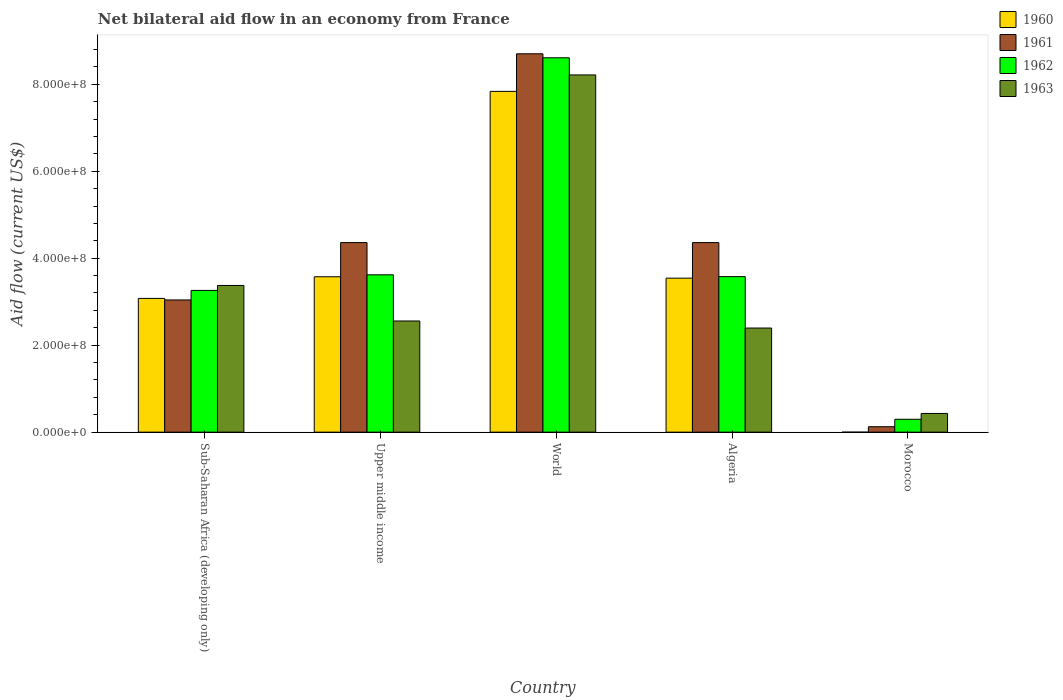How many different coloured bars are there?
Keep it short and to the point. 4. Are the number of bars on each tick of the X-axis equal?
Give a very brief answer. No. How many bars are there on the 4th tick from the left?
Your response must be concise. 4. What is the label of the 2nd group of bars from the left?
Ensure brevity in your answer.  Upper middle income. What is the net bilateral aid flow in 1963 in World?
Give a very brief answer. 8.21e+08. Across all countries, what is the maximum net bilateral aid flow in 1960?
Provide a short and direct response. 7.84e+08. Across all countries, what is the minimum net bilateral aid flow in 1962?
Make the answer very short. 2.96e+07. In which country was the net bilateral aid flow in 1960 maximum?
Give a very brief answer. World. What is the total net bilateral aid flow in 1960 in the graph?
Give a very brief answer. 1.80e+09. What is the difference between the net bilateral aid flow in 1962 in Algeria and that in Morocco?
Provide a succinct answer. 3.28e+08. What is the difference between the net bilateral aid flow in 1961 in Sub-Saharan Africa (developing only) and the net bilateral aid flow in 1962 in Algeria?
Make the answer very short. -5.36e+07. What is the average net bilateral aid flow in 1960 per country?
Offer a terse response. 3.60e+08. What is the difference between the net bilateral aid flow of/in 1961 and net bilateral aid flow of/in 1962 in Sub-Saharan Africa (developing only)?
Provide a succinct answer. -2.19e+07. In how many countries, is the net bilateral aid flow in 1962 greater than 80000000 US$?
Offer a very short reply. 4. What is the ratio of the net bilateral aid flow in 1963 in Morocco to that in Sub-Saharan Africa (developing only)?
Make the answer very short. 0.13. Is the net bilateral aid flow in 1963 in Morocco less than that in Sub-Saharan Africa (developing only)?
Your response must be concise. Yes. Is the difference between the net bilateral aid flow in 1961 in Morocco and World greater than the difference between the net bilateral aid flow in 1962 in Morocco and World?
Your answer should be compact. No. What is the difference between the highest and the second highest net bilateral aid flow in 1961?
Offer a terse response. 4.34e+08. What is the difference between the highest and the lowest net bilateral aid flow in 1961?
Provide a succinct answer. 8.58e+08. Is the sum of the net bilateral aid flow in 1960 in Algeria and World greater than the maximum net bilateral aid flow in 1961 across all countries?
Keep it short and to the point. Yes. Is it the case that in every country, the sum of the net bilateral aid flow in 1962 and net bilateral aid flow in 1961 is greater than the net bilateral aid flow in 1963?
Your response must be concise. No. What is the difference between two consecutive major ticks on the Y-axis?
Your response must be concise. 2.00e+08. Are the values on the major ticks of Y-axis written in scientific E-notation?
Keep it short and to the point. Yes. Does the graph contain any zero values?
Provide a succinct answer. Yes. Where does the legend appear in the graph?
Your answer should be compact. Top right. How many legend labels are there?
Give a very brief answer. 4. What is the title of the graph?
Make the answer very short. Net bilateral aid flow in an economy from France. What is the label or title of the Y-axis?
Keep it short and to the point. Aid flow (current US$). What is the Aid flow (current US$) in 1960 in Sub-Saharan Africa (developing only)?
Ensure brevity in your answer.  3.08e+08. What is the Aid flow (current US$) of 1961 in Sub-Saharan Africa (developing only)?
Give a very brief answer. 3.04e+08. What is the Aid flow (current US$) in 1962 in Sub-Saharan Africa (developing only)?
Offer a terse response. 3.26e+08. What is the Aid flow (current US$) in 1963 in Sub-Saharan Africa (developing only)?
Offer a terse response. 3.37e+08. What is the Aid flow (current US$) of 1960 in Upper middle income?
Your response must be concise. 3.57e+08. What is the Aid flow (current US$) of 1961 in Upper middle income?
Offer a very short reply. 4.36e+08. What is the Aid flow (current US$) in 1962 in Upper middle income?
Ensure brevity in your answer.  3.62e+08. What is the Aid flow (current US$) in 1963 in Upper middle income?
Your answer should be very brief. 2.56e+08. What is the Aid flow (current US$) in 1960 in World?
Ensure brevity in your answer.  7.84e+08. What is the Aid flow (current US$) of 1961 in World?
Keep it short and to the point. 8.70e+08. What is the Aid flow (current US$) in 1962 in World?
Provide a succinct answer. 8.61e+08. What is the Aid flow (current US$) in 1963 in World?
Keep it short and to the point. 8.21e+08. What is the Aid flow (current US$) of 1960 in Algeria?
Your response must be concise. 3.54e+08. What is the Aid flow (current US$) in 1961 in Algeria?
Make the answer very short. 4.36e+08. What is the Aid flow (current US$) in 1962 in Algeria?
Give a very brief answer. 3.58e+08. What is the Aid flow (current US$) of 1963 in Algeria?
Offer a very short reply. 2.39e+08. What is the Aid flow (current US$) in 1961 in Morocco?
Give a very brief answer. 1.25e+07. What is the Aid flow (current US$) of 1962 in Morocco?
Make the answer very short. 2.96e+07. What is the Aid flow (current US$) of 1963 in Morocco?
Provide a succinct answer. 4.30e+07. Across all countries, what is the maximum Aid flow (current US$) in 1960?
Your answer should be compact. 7.84e+08. Across all countries, what is the maximum Aid flow (current US$) in 1961?
Ensure brevity in your answer.  8.70e+08. Across all countries, what is the maximum Aid flow (current US$) of 1962?
Give a very brief answer. 8.61e+08. Across all countries, what is the maximum Aid flow (current US$) of 1963?
Your response must be concise. 8.21e+08. Across all countries, what is the minimum Aid flow (current US$) in 1961?
Your answer should be very brief. 1.25e+07. Across all countries, what is the minimum Aid flow (current US$) in 1962?
Offer a terse response. 2.96e+07. Across all countries, what is the minimum Aid flow (current US$) of 1963?
Give a very brief answer. 4.30e+07. What is the total Aid flow (current US$) of 1960 in the graph?
Offer a very short reply. 1.80e+09. What is the total Aid flow (current US$) of 1961 in the graph?
Give a very brief answer. 2.06e+09. What is the total Aid flow (current US$) in 1962 in the graph?
Ensure brevity in your answer.  1.94e+09. What is the total Aid flow (current US$) of 1963 in the graph?
Offer a very short reply. 1.70e+09. What is the difference between the Aid flow (current US$) in 1960 in Sub-Saharan Africa (developing only) and that in Upper middle income?
Offer a terse response. -4.98e+07. What is the difference between the Aid flow (current US$) in 1961 in Sub-Saharan Africa (developing only) and that in Upper middle income?
Keep it short and to the point. -1.32e+08. What is the difference between the Aid flow (current US$) in 1962 in Sub-Saharan Africa (developing only) and that in Upper middle income?
Your answer should be compact. -3.59e+07. What is the difference between the Aid flow (current US$) in 1963 in Sub-Saharan Africa (developing only) and that in Upper middle income?
Keep it short and to the point. 8.17e+07. What is the difference between the Aid flow (current US$) of 1960 in Sub-Saharan Africa (developing only) and that in World?
Keep it short and to the point. -4.76e+08. What is the difference between the Aid flow (current US$) of 1961 in Sub-Saharan Africa (developing only) and that in World?
Provide a short and direct response. -5.66e+08. What is the difference between the Aid flow (current US$) of 1962 in Sub-Saharan Africa (developing only) and that in World?
Your response must be concise. -5.35e+08. What is the difference between the Aid flow (current US$) of 1963 in Sub-Saharan Africa (developing only) and that in World?
Your response must be concise. -4.84e+08. What is the difference between the Aid flow (current US$) of 1960 in Sub-Saharan Africa (developing only) and that in Algeria?
Your answer should be compact. -4.66e+07. What is the difference between the Aid flow (current US$) in 1961 in Sub-Saharan Africa (developing only) and that in Algeria?
Your response must be concise. -1.32e+08. What is the difference between the Aid flow (current US$) in 1962 in Sub-Saharan Africa (developing only) and that in Algeria?
Offer a very short reply. -3.17e+07. What is the difference between the Aid flow (current US$) of 1963 in Sub-Saharan Africa (developing only) and that in Algeria?
Ensure brevity in your answer.  9.79e+07. What is the difference between the Aid flow (current US$) of 1961 in Sub-Saharan Africa (developing only) and that in Morocco?
Offer a terse response. 2.92e+08. What is the difference between the Aid flow (current US$) in 1962 in Sub-Saharan Africa (developing only) and that in Morocco?
Offer a very short reply. 2.96e+08. What is the difference between the Aid flow (current US$) in 1963 in Sub-Saharan Africa (developing only) and that in Morocco?
Ensure brevity in your answer.  2.94e+08. What is the difference between the Aid flow (current US$) in 1960 in Upper middle income and that in World?
Your response must be concise. -4.26e+08. What is the difference between the Aid flow (current US$) of 1961 in Upper middle income and that in World?
Offer a very short reply. -4.34e+08. What is the difference between the Aid flow (current US$) in 1962 in Upper middle income and that in World?
Give a very brief answer. -4.99e+08. What is the difference between the Aid flow (current US$) in 1963 in Upper middle income and that in World?
Offer a terse response. -5.66e+08. What is the difference between the Aid flow (current US$) in 1960 in Upper middle income and that in Algeria?
Your answer should be compact. 3.20e+06. What is the difference between the Aid flow (current US$) in 1962 in Upper middle income and that in Algeria?
Offer a terse response. 4.20e+06. What is the difference between the Aid flow (current US$) of 1963 in Upper middle income and that in Algeria?
Ensure brevity in your answer.  1.62e+07. What is the difference between the Aid flow (current US$) of 1961 in Upper middle income and that in Morocco?
Your answer should be compact. 4.23e+08. What is the difference between the Aid flow (current US$) of 1962 in Upper middle income and that in Morocco?
Provide a succinct answer. 3.32e+08. What is the difference between the Aid flow (current US$) in 1963 in Upper middle income and that in Morocco?
Your answer should be compact. 2.13e+08. What is the difference between the Aid flow (current US$) in 1960 in World and that in Algeria?
Your answer should be very brief. 4.30e+08. What is the difference between the Aid flow (current US$) of 1961 in World and that in Algeria?
Provide a succinct answer. 4.34e+08. What is the difference between the Aid flow (current US$) in 1962 in World and that in Algeria?
Offer a very short reply. 5.03e+08. What is the difference between the Aid flow (current US$) in 1963 in World and that in Algeria?
Your answer should be very brief. 5.82e+08. What is the difference between the Aid flow (current US$) in 1961 in World and that in Morocco?
Your answer should be compact. 8.58e+08. What is the difference between the Aid flow (current US$) of 1962 in World and that in Morocco?
Offer a terse response. 8.31e+08. What is the difference between the Aid flow (current US$) of 1963 in World and that in Morocco?
Give a very brief answer. 7.78e+08. What is the difference between the Aid flow (current US$) of 1961 in Algeria and that in Morocco?
Provide a succinct answer. 4.23e+08. What is the difference between the Aid flow (current US$) in 1962 in Algeria and that in Morocco?
Your answer should be very brief. 3.28e+08. What is the difference between the Aid flow (current US$) of 1963 in Algeria and that in Morocco?
Make the answer very short. 1.96e+08. What is the difference between the Aid flow (current US$) in 1960 in Sub-Saharan Africa (developing only) and the Aid flow (current US$) in 1961 in Upper middle income?
Keep it short and to the point. -1.28e+08. What is the difference between the Aid flow (current US$) of 1960 in Sub-Saharan Africa (developing only) and the Aid flow (current US$) of 1962 in Upper middle income?
Give a very brief answer. -5.43e+07. What is the difference between the Aid flow (current US$) of 1960 in Sub-Saharan Africa (developing only) and the Aid flow (current US$) of 1963 in Upper middle income?
Keep it short and to the point. 5.19e+07. What is the difference between the Aid flow (current US$) of 1961 in Sub-Saharan Africa (developing only) and the Aid flow (current US$) of 1962 in Upper middle income?
Make the answer very short. -5.78e+07. What is the difference between the Aid flow (current US$) in 1961 in Sub-Saharan Africa (developing only) and the Aid flow (current US$) in 1963 in Upper middle income?
Give a very brief answer. 4.84e+07. What is the difference between the Aid flow (current US$) in 1962 in Sub-Saharan Africa (developing only) and the Aid flow (current US$) in 1963 in Upper middle income?
Make the answer very short. 7.03e+07. What is the difference between the Aid flow (current US$) of 1960 in Sub-Saharan Africa (developing only) and the Aid flow (current US$) of 1961 in World?
Give a very brief answer. -5.62e+08. What is the difference between the Aid flow (current US$) in 1960 in Sub-Saharan Africa (developing only) and the Aid flow (current US$) in 1962 in World?
Make the answer very short. -5.53e+08. What is the difference between the Aid flow (current US$) of 1960 in Sub-Saharan Africa (developing only) and the Aid flow (current US$) of 1963 in World?
Your response must be concise. -5.14e+08. What is the difference between the Aid flow (current US$) in 1961 in Sub-Saharan Africa (developing only) and the Aid flow (current US$) in 1962 in World?
Provide a succinct answer. -5.57e+08. What is the difference between the Aid flow (current US$) in 1961 in Sub-Saharan Africa (developing only) and the Aid flow (current US$) in 1963 in World?
Make the answer very short. -5.17e+08. What is the difference between the Aid flow (current US$) of 1962 in Sub-Saharan Africa (developing only) and the Aid flow (current US$) of 1963 in World?
Provide a succinct answer. -4.96e+08. What is the difference between the Aid flow (current US$) of 1960 in Sub-Saharan Africa (developing only) and the Aid flow (current US$) of 1961 in Algeria?
Provide a short and direct response. -1.28e+08. What is the difference between the Aid flow (current US$) in 1960 in Sub-Saharan Africa (developing only) and the Aid flow (current US$) in 1962 in Algeria?
Your answer should be very brief. -5.01e+07. What is the difference between the Aid flow (current US$) of 1960 in Sub-Saharan Africa (developing only) and the Aid flow (current US$) of 1963 in Algeria?
Keep it short and to the point. 6.81e+07. What is the difference between the Aid flow (current US$) of 1961 in Sub-Saharan Africa (developing only) and the Aid flow (current US$) of 1962 in Algeria?
Ensure brevity in your answer.  -5.36e+07. What is the difference between the Aid flow (current US$) of 1961 in Sub-Saharan Africa (developing only) and the Aid flow (current US$) of 1963 in Algeria?
Give a very brief answer. 6.46e+07. What is the difference between the Aid flow (current US$) of 1962 in Sub-Saharan Africa (developing only) and the Aid flow (current US$) of 1963 in Algeria?
Your answer should be very brief. 8.65e+07. What is the difference between the Aid flow (current US$) in 1960 in Sub-Saharan Africa (developing only) and the Aid flow (current US$) in 1961 in Morocco?
Your answer should be very brief. 2.95e+08. What is the difference between the Aid flow (current US$) in 1960 in Sub-Saharan Africa (developing only) and the Aid flow (current US$) in 1962 in Morocco?
Make the answer very short. 2.78e+08. What is the difference between the Aid flow (current US$) of 1960 in Sub-Saharan Africa (developing only) and the Aid flow (current US$) of 1963 in Morocco?
Keep it short and to the point. 2.64e+08. What is the difference between the Aid flow (current US$) in 1961 in Sub-Saharan Africa (developing only) and the Aid flow (current US$) in 1962 in Morocco?
Your answer should be compact. 2.74e+08. What is the difference between the Aid flow (current US$) in 1961 in Sub-Saharan Africa (developing only) and the Aid flow (current US$) in 1963 in Morocco?
Keep it short and to the point. 2.61e+08. What is the difference between the Aid flow (current US$) in 1962 in Sub-Saharan Africa (developing only) and the Aid flow (current US$) in 1963 in Morocco?
Give a very brief answer. 2.83e+08. What is the difference between the Aid flow (current US$) in 1960 in Upper middle income and the Aid flow (current US$) in 1961 in World?
Give a very brief answer. -5.13e+08. What is the difference between the Aid flow (current US$) of 1960 in Upper middle income and the Aid flow (current US$) of 1962 in World?
Keep it short and to the point. -5.04e+08. What is the difference between the Aid flow (current US$) of 1960 in Upper middle income and the Aid flow (current US$) of 1963 in World?
Make the answer very short. -4.64e+08. What is the difference between the Aid flow (current US$) of 1961 in Upper middle income and the Aid flow (current US$) of 1962 in World?
Your response must be concise. -4.25e+08. What is the difference between the Aid flow (current US$) in 1961 in Upper middle income and the Aid flow (current US$) in 1963 in World?
Provide a short and direct response. -3.86e+08. What is the difference between the Aid flow (current US$) in 1962 in Upper middle income and the Aid flow (current US$) in 1963 in World?
Offer a terse response. -4.60e+08. What is the difference between the Aid flow (current US$) in 1960 in Upper middle income and the Aid flow (current US$) in 1961 in Algeria?
Your response must be concise. -7.86e+07. What is the difference between the Aid flow (current US$) of 1960 in Upper middle income and the Aid flow (current US$) of 1963 in Algeria?
Provide a succinct answer. 1.18e+08. What is the difference between the Aid flow (current US$) of 1961 in Upper middle income and the Aid flow (current US$) of 1962 in Algeria?
Keep it short and to the point. 7.83e+07. What is the difference between the Aid flow (current US$) in 1961 in Upper middle income and the Aid flow (current US$) in 1963 in Algeria?
Make the answer very short. 1.96e+08. What is the difference between the Aid flow (current US$) of 1962 in Upper middle income and the Aid flow (current US$) of 1963 in Algeria?
Your answer should be compact. 1.22e+08. What is the difference between the Aid flow (current US$) in 1960 in Upper middle income and the Aid flow (current US$) in 1961 in Morocco?
Your answer should be very brief. 3.45e+08. What is the difference between the Aid flow (current US$) of 1960 in Upper middle income and the Aid flow (current US$) of 1962 in Morocco?
Keep it short and to the point. 3.28e+08. What is the difference between the Aid flow (current US$) in 1960 in Upper middle income and the Aid flow (current US$) in 1963 in Morocco?
Provide a succinct answer. 3.14e+08. What is the difference between the Aid flow (current US$) of 1961 in Upper middle income and the Aid flow (current US$) of 1962 in Morocco?
Provide a succinct answer. 4.06e+08. What is the difference between the Aid flow (current US$) in 1961 in Upper middle income and the Aid flow (current US$) in 1963 in Morocco?
Offer a very short reply. 3.93e+08. What is the difference between the Aid flow (current US$) of 1962 in Upper middle income and the Aid flow (current US$) of 1963 in Morocco?
Make the answer very short. 3.19e+08. What is the difference between the Aid flow (current US$) in 1960 in World and the Aid flow (current US$) in 1961 in Algeria?
Make the answer very short. 3.48e+08. What is the difference between the Aid flow (current US$) in 1960 in World and the Aid flow (current US$) in 1962 in Algeria?
Provide a short and direct response. 4.26e+08. What is the difference between the Aid flow (current US$) in 1960 in World and the Aid flow (current US$) in 1963 in Algeria?
Your answer should be very brief. 5.44e+08. What is the difference between the Aid flow (current US$) in 1961 in World and the Aid flow (current US$) in 1962 in Algeria?
Keep it short and to the point. 5.12e+08. What is the difference between the Aid flow (current US$) in 1961 in World and the Aid flow (current US$) in 1963 in Algeria?
Your response must be concise. 6.31e+08. What is the difference between the Aid flow (current US$) of 1962 in World and the Aid flow (current US$) of 1963 in Algeria?
Give a very brief answer. 6.21e+08. What is the difference between the Aid flow (current US$) of 1960 in World and the Aid flow (current US$) of 1961 in Morocco?
Make the answer very short. 7.71e+08. What is the difference between the Aid flow (current US$) in 1960 in World and the Aid flow (current US$) in 1962 in Morocco?
Your answer should be compact. 7.54e+08. What is the difference between the Aid flow (current US$) in 1960 in World and the Aid flow (current US$) in 1963 in Morocco?
Your answer should be compact. 7.41e+08. What is the difference between the Aid flow (current US$) in 1961 in World and the Aid flow (current US$) in 1962 in Morocco?
Provide a short and direct response. 8.40e+08. What is the difference between the Aid flow (current US$) of 1961 in World and the Aid flow (current US$) of 1963 in Morocco?
Provide a short and direct response. 8.27e+08. What is the difference between the Aid flow (current US$) in 1962 in World and the Aid flow (current US$) in 1963 in Morocco?
Offer a terse response. 8.18e+08. What is the difference between the Aid flow (current US$) in 1960 in Algeria and the Aid flow (current US$) in 1961 in Morocco?
Make the answer very short. 3.42e+08. What is the difference between the Aid flow (current US$) in 1960 in Algeria and the Aid flow (current US$) in 1962 in Morocco?
Ensure brevity in your answer.  3.24e+08. What is the difference between the Aid flow (current US$) of 1960 in Algeria and the Aid flow (current US$) of 1963 in Morocco?
Offer a terse response. 3.11e+08. What is the difference between the Aid flow (current US$) in 1961 in Algeria and the Aid flow (current US$) in 1962 in Morocco?
Offer a terse response. 4.06e+08. What is the difference between the Aid flow (current US$) of 1961 in Algeria and the Aid flow (current US$) of 1963 in Morocco?
Your response must be concise. 3.93e+08. What is the difference between the Aid flow (current US$) of 1962 in Algeria and the Aid flow (current US$) of 1963 in Morocco?
Your answer should be compact. 3.15e+08. What is the average Aid flow (current US$) of 1960 per country?
Offer a terse response. 3.60e+08. What is the average Aid flow (current US$) in 1961 per country?
Provide a short and direct response. 4.12e+08. What is the average Aid flow (current US$) of 1962 per country?
Keep it short and to the point. 3.87e+08. What is the average Aid flow (current US$) in 1963 per country?
Your response must be concise. 3.39e+08. What is the difference between the Aid flow (current US$) in 1960 and Aid flow (current US$) in 1961 in Sub-Saharan Africa (developing only)?
Make the answer very short. 3.50e+06. What is the difference between the Aid flow (current US$) of 1960 and Aid flow (current US$) of 1962 in Sub-Saharan Africa (developing only)?
Offer a terse response. -1.84e+07. What is the difference between the Aid flow (current US$) in 1960 and Aid flow (current US$) in 1963 in Sub-Saharan Africa (developing only)?
Offer a very short reply. -2.98e+07. What is the difference between the Aid flow (current US$) in 1961 and Aid flow (current US$) in 1962 in Sub-Saharan Africa (developing only)?
Your answer should be compact. -2.19e+07. What is the difference between the Aid flow (current US$) in 1961 and Aid flow (current US$) in 1963 in Sub-Saharan Africa (developing only)?
Offer a terse response. -3.33e+07. What is the difference between the Aid flow (current US$) in 1962 and Aid flow (current US$) in 1963 in Sub-Saharan Africa (developing only)?
Make the answer very short. -1.14e+07. What is the difference between the Aid flow (current US$) of 1960 and Aid flow (current US$) of 1961 in Upper middle income?
Provide a succinct answer. -7.86e+07. What is the difference between the Aid flow (current US$) in 1960 and Aid flow (current US$) in 1962 in Upper middle income?
Keep it short and to the point. -4.50e+06. What is the difference between the Aid flow (current US$) in 1960 and Aid flow (current US$) in 1963 in Upper middle income?
Offer a very short reply. 1.02e+08. What is the difference between the Aid flow (current US$) in 1961 and Aid flow (current US$) in 1962 in Upper middle income?
Give a very brief answer. 7.41e+07. What is the difference between the Aid flow (current US$) in 1961 and Aid flow (current US$) in 1963 in Upper middle income?
Make the answer very short. 1.80e+08. What is the difference between the Aid flow (current US$) in 1962 and Aid flow (current US$) in 1963 in Upper middle income?
Offer a very short reply. 1.06e+08. What is the difference between the Aid flow (current US$) in 1960 and Aid flow (current US$) in 1961 in World?
Make the answer very short. -8.64e+07. What is the difference between the Aid flow (current US$) in 1960 and Aid flow (current US$) in 1962 in World?
Your answer should be compact. -7.72e+07. What is the difference between the Aid flow (current US$) in 1960 and Aid flow (current US$) in 1963 in World?
Offer a very short reply. -3.78e+07. What is the difference between the Aid flow (current US$) of 1961 and Aid flow (current US$) of 1962 in World?
Keep it short and to the point. 9.20e+06. What is the difference between the Aid flow (current US$) in 1961 and Aid flow (current US$) in 1963 in World?
Your response must be concise. 4.86e+07. What is the difference between the Aid flow (current US$) in 1962 and Aid flow (current US$) in 1963 in World?
Your answer should be compact. 3.94e+07. What is the difference between the Aid flow (current US$) in 1960 and Aid flow (current US$) in 1961 in Algeria?
Your response must be concise. -8.18e+07. What is the difference between the Aid flow (current US$) of 1960 and Aid flow (current US$) of 1962 in Algeria?
Keep it short and to the point. -3.50e+06. What is the difference between the Aid flow (current US$) in 1960 and Aid flow (current US$) in 1963 in Algeria?
Give a very brief answer. 1.15e+08. What is the difference between the Aid flow (current US$) of 1961 and Aid flow (current US$) of 1962 in Algeria?
Give a very brief answer. 7.83e+07. What is the difference between the Aid flow (current US$) of 1961 and Aid flow (current US$) of 1963 in Algeria?
Keep it short and to the point. 1.96e+08. What is the difference between the Aid flow (current US$) in 1962 and Aid flow (current US$) in 1963 in Algeria?
Offer a terse response. 1.18e+08. What is the difference between the Aid flow (current US$) in 1961 and Aid flow (current US$) in 1962 in Morocco?
Provide a short and direct response. -1.71e+07. What is the difference between the Aid flow (current US$) in 1961 and Aid flow (current US$) in 1963 in Morocco?
Offer a terse response. -3.05e+07. What is the difference between the Aid flow (current US$) of 1962 and Aid flow (current US$) of 1963 in Morocco?
Provide a succinct answer. -1.34e+07. What is the ratio of the Aid flow (current US$) in 1960 in Sub-Saharan Africa (developing only) to that in Upper middle income?
Your response must be concise. 0.86. What is the ratio of the Aid flow (current US$) of 1961 in Sub-Saharan Africa (developing only) to that in Upper middle income?
Offer a very short reply. 0.7. What is the ratio of the Aid flow (current US$) of 1962 in Sub-Saharan Africa (developing only) to that in Upper middle income?
Provide a short and direct response. 0.9. What is the ratio of the Aid flow (current US$) of 1963 in Sub-Saharan Africa (developing only) to that in Upper middle income?
Provide a succinct answer. 1.32. What is the ratio of the Aid flow (current US$) of 1960 in Sub-Saharan Africa (developing only) to that in World?
Offer a terse response. 0.39. What is the ratio of the Aid flow (current US$) in 1961 in Sub-Saharan Africa (developing only) to that in World?
Give a very brief answer. 0.35. What is the ratio of the Aid flow (current US$) of 1962 in Sub-Saharan Africa (developing only) to that in World?
Offer a very short reply. 0.38. What is the ratio of the Aid flow (current US$) in 1963 in Sub-Saharan Africa (developing only) to that in World?
Offer a very short reply. 0.41. What is the ratio of the Aid flow (current US$) of 1960 in Sub-Saharan Africa (developing only) to that in Algeria?
Your response must be concise. 0.87. What is the ratio of the Aid flow (current US$) of 1961 in Sub-Saharan Africa (developing only) to that in Algeria?
Offer a very short reply. 0.7. What is the ratio of the Aid flow (current US$) in 1962 in Sub-Saharan Africa (developing only) to that in Algeria?
Offer a terse response. 0.91. What is the ratio of the Aid flow (current US$) in 1963 in Sub-Saharan Africa (developing only) to that in Algeria?
Make the answer very short. 1.41. What is the ratio of the Aid flow (current US$) of 1961 in Sub-Saharan Africa (developing only) to that in Morocco?
Give a very brief answer. 24.32. What is the ratio of the Aid flow (current US$) in 1962 in Sub-Saharan Africa (developing only) to that in Morocco?
Keep it short and to the point. 11.01. What is the ratio of the Aid flow (current US$) in 1963 in Sub-Saharan Africa (developing only) to that in Morocco?
Give a very brief answer. 7.84. What is the ratio of the Aid flow (current US$) in 1960 in Upper middle income to that in World?
Your answer should be compact. 0.46. What is the ratio of the Aid flow (current US$) of 1961 in Upper middle income to that in World?
Offer a terse response. 0.5. What is the ratio of the Aid flow (current US$) in 1962 in Upper middle income to that in World?
Give a very brief answer. 0.42. What is the ratio of the Aid flow (current US$) in 1963 in Upper middle income to that in World?
Ensure brevity in your answer.  0.31. What is the ratio of the Aid flow (current US$) in 1960 in Upper middle income to that in Algeria?
Provide a short and direct response. 1.01. What is the ratio of the Aid flow (current US$) in 1962 in Upper middle income to that in Algeria?
Offer a very short reply. 1.01. What is the ratio of the Aid flow (current US$) of 1963 in Upper middle income to that in Algeria?
Your answer should be very brief. 1.07. What is the ratio of the Aid flow (current US$) in 1961 in Upper middle income to that in Morocco?
Your answer should be compact. 34.87. What is the ratio of the Aid flow (current US$) of 1962 in Upper middle income to that in Morocco?
Your answer should be compact. 12.22. What is the ratio of the Aid flow (current US$) of 1963 in Upper middle income to that in Morocco?
Give a very brief answer. 5.94. What is the ratio of the Aid flow (current US$) in 1960 in World to that in Algeria?
Make the answer very short. 2.21. What is the ratio of the Aid flow (current US$) of 1961 in World to that in Algeria?
Provide a succinct answer. 2. What is the ratio of the Aid flow (current US$) of 1962 in World to that in Algeria?
Make the answer very short. 2.41. What is the ratio of the Aid flow (current US$) in 1963 in World to that in Algeria?
Provide a succinct answer. 3.43. What is the ratio of the Aid flow (current US$) of 1961 in World to that in Morocco?
Your answer should be very brief. 69.6. What is the ratio of the Aid flow (current US$) in 1962 in World to that in Morocco?
Your answer should be compact. 29.08. What is the ratio of the Aid flow (current US$) of 1963 in World to that in Morocco?
Give a very brief answer. 19.1. What is the ratio of the Aid flow (current US$) of 1961 in Algeria to that in Morocco?
Ensure brevity in your answer.  34.87. What is the ratio of the Aid flow (current US$) in 1962 in Algeria to that in Morocco?
Offer a terse response. 12.08. What is the ratio of the Aid flow (current US$) in 1963 in Algeria to that in Morocco?
Keep it short and to the point. 5.57. What is the difference between the highest and the second highest Aid flow (current US$) of 1960?
Offer a terse response. 4.26e+08. What is the difference between the highest and the second highest Aid flow (current US$) of 1961?
Provide a succinct answer. 4.34e+08. What is the difference between the highest and the second highest Aid flow (current US$) in 1962?
Provide a short and direct response. 4.99e+08. What is the difference between the highest and the second highest Aid flow (current US$) of 1963?
Your answer should be compact. 4.84e+08. What is the difference between the highest and the lowest Aid flow (current US$) in 1960?
Provide a succinct answer. 7.84e+08. What is the difference between the highest and the lowest Aid flow (current US$) in 1961?
Your answer should be very brief. 8.58e+08. What is the difference between the highest and the lowest Aid flow (current US$) of 1962?
Your answer should be very brief. 8.31e+08. What is the difference between the highest and the lowest Aid flow (current US$) of 1963?
Offer a terse response. 7.78e+08. 